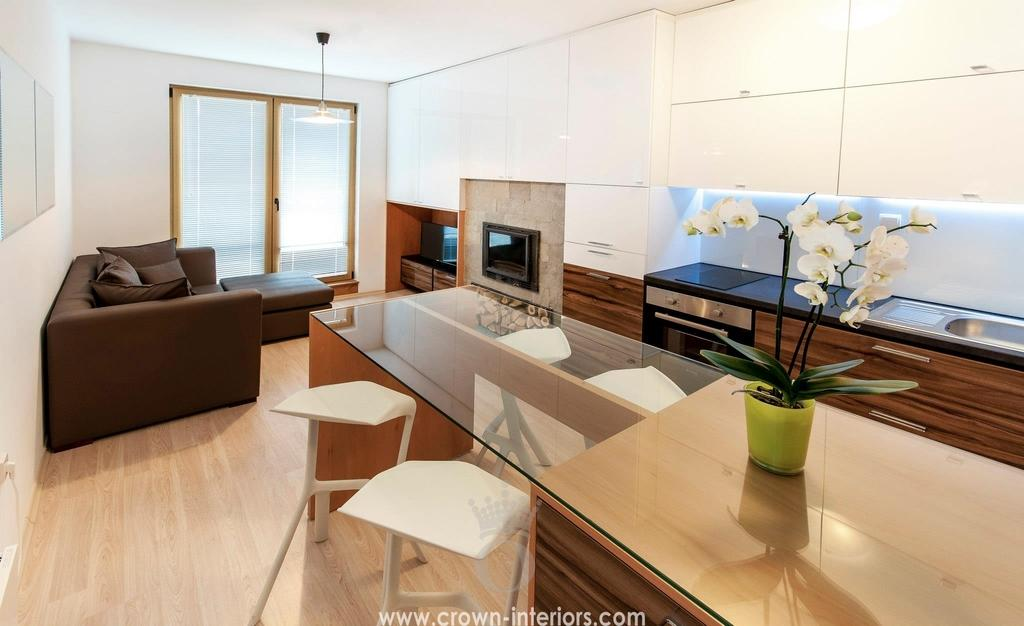What type of space is depicted in the image? There is a room in the image. What can be found on a table in the room? There is a flower vase on a table in the room. What type of furniture is present in the room? There is a couch in the room. What surface is used for preparing or storing items in the room? There is a countertop in the room. What is used for washing or cleaning in the room? There is a sink in the room. How can one enter or exit the room? There is a door in the room. What type of blade is being used in the discussion in the image? There is no discussion or blade present in the image; it only shows a room with various objects and furniture. 